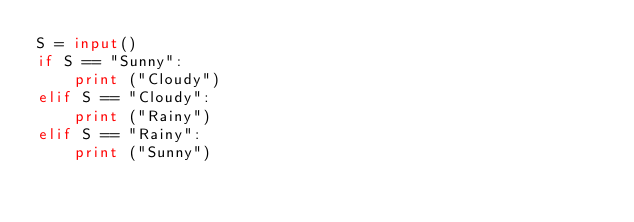Convert code to text. <code><loc_0><loc_0><loc_500><loc_500><_Python_>S = input()
if S == "Sunny":
    print ("Cloudy")
elif S == "Cloudy":
    print ("Rainy")
elif S == "Rainy":
    print ("Sunny")</code> 